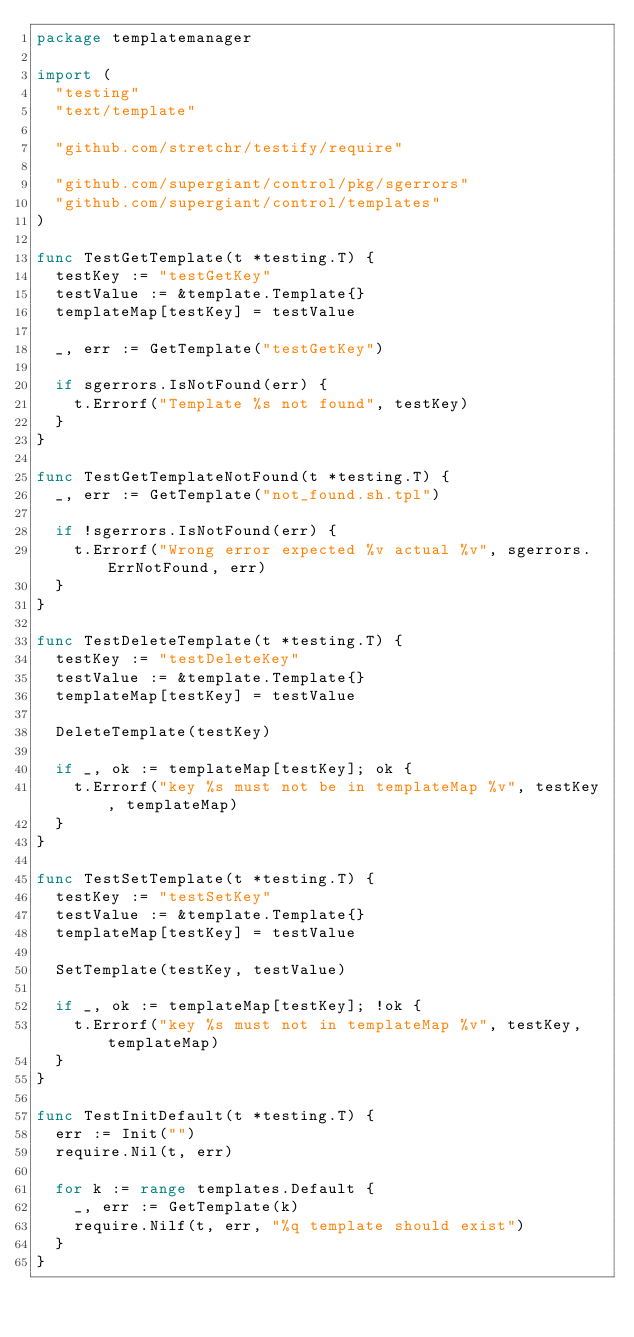<code> <loc_0><loc_0><loc_500><loc_500><_Go_>package templatemanager

import (
	"testing"
	"text/template"

	"github.com/stretchr/testify/require"

	"github.com/supergiant/control/pkg/sgerrors"
	"github.com/supergiant/control/templates"
)

func TestGetTemplate(t *testing.T) {
	testKey := "testGetKey"
	testValue := &template.Template{}
	templateMap[testKey] = testValue

	_, err := GetTemplate("testGetKey")

	if sgerrors.IsNotFound(err) {
		t.Errorf("Template %s not found", testKey)
	}
}

func TestGetTemplateNotFound(t *testing.T) {
	_, err := GetTemplate("not_found.sh.tpl")

	if !sgerrors.IsNotFound(err) {
		t.Errorf("Wrong error expected %v actual %v", sgerrors.ErrNotFound, err)
	}
}

func TestDeleteTemplate(t *testing.T) {
	testKey := "testDeleteKey"
	testValue := &template.Template{}
	templateMap[testKey] = testValue

	DeleteTemplate(testKey)

	if _, ok := templateMap[testKey]; ok {
		t.Errorf("key %s must not be in templateMap %v", testKey, templateMap)
	}
}

func TestSetTemplate(t *testing.T) {
	testKey := "testSetKey"
	testValue := &template.Template{}
	templateMap[testKey] = testValue

	SetTemplate(testKey, testValue)

	if _, ok := templateMap[testKey]; !ok {
		t.Errorf("key %s must not in templateMap %v", testKey, templateMap)
	}
}

func TestInitDefault(t *testing.T) {
	err := Init("")
	require.Nil(t, err)

	for k := range templates.Default {
		_, err := GetTemplate(k)
		require.Nilf(t, err, "%q template should exist")
	}
}
</code> 